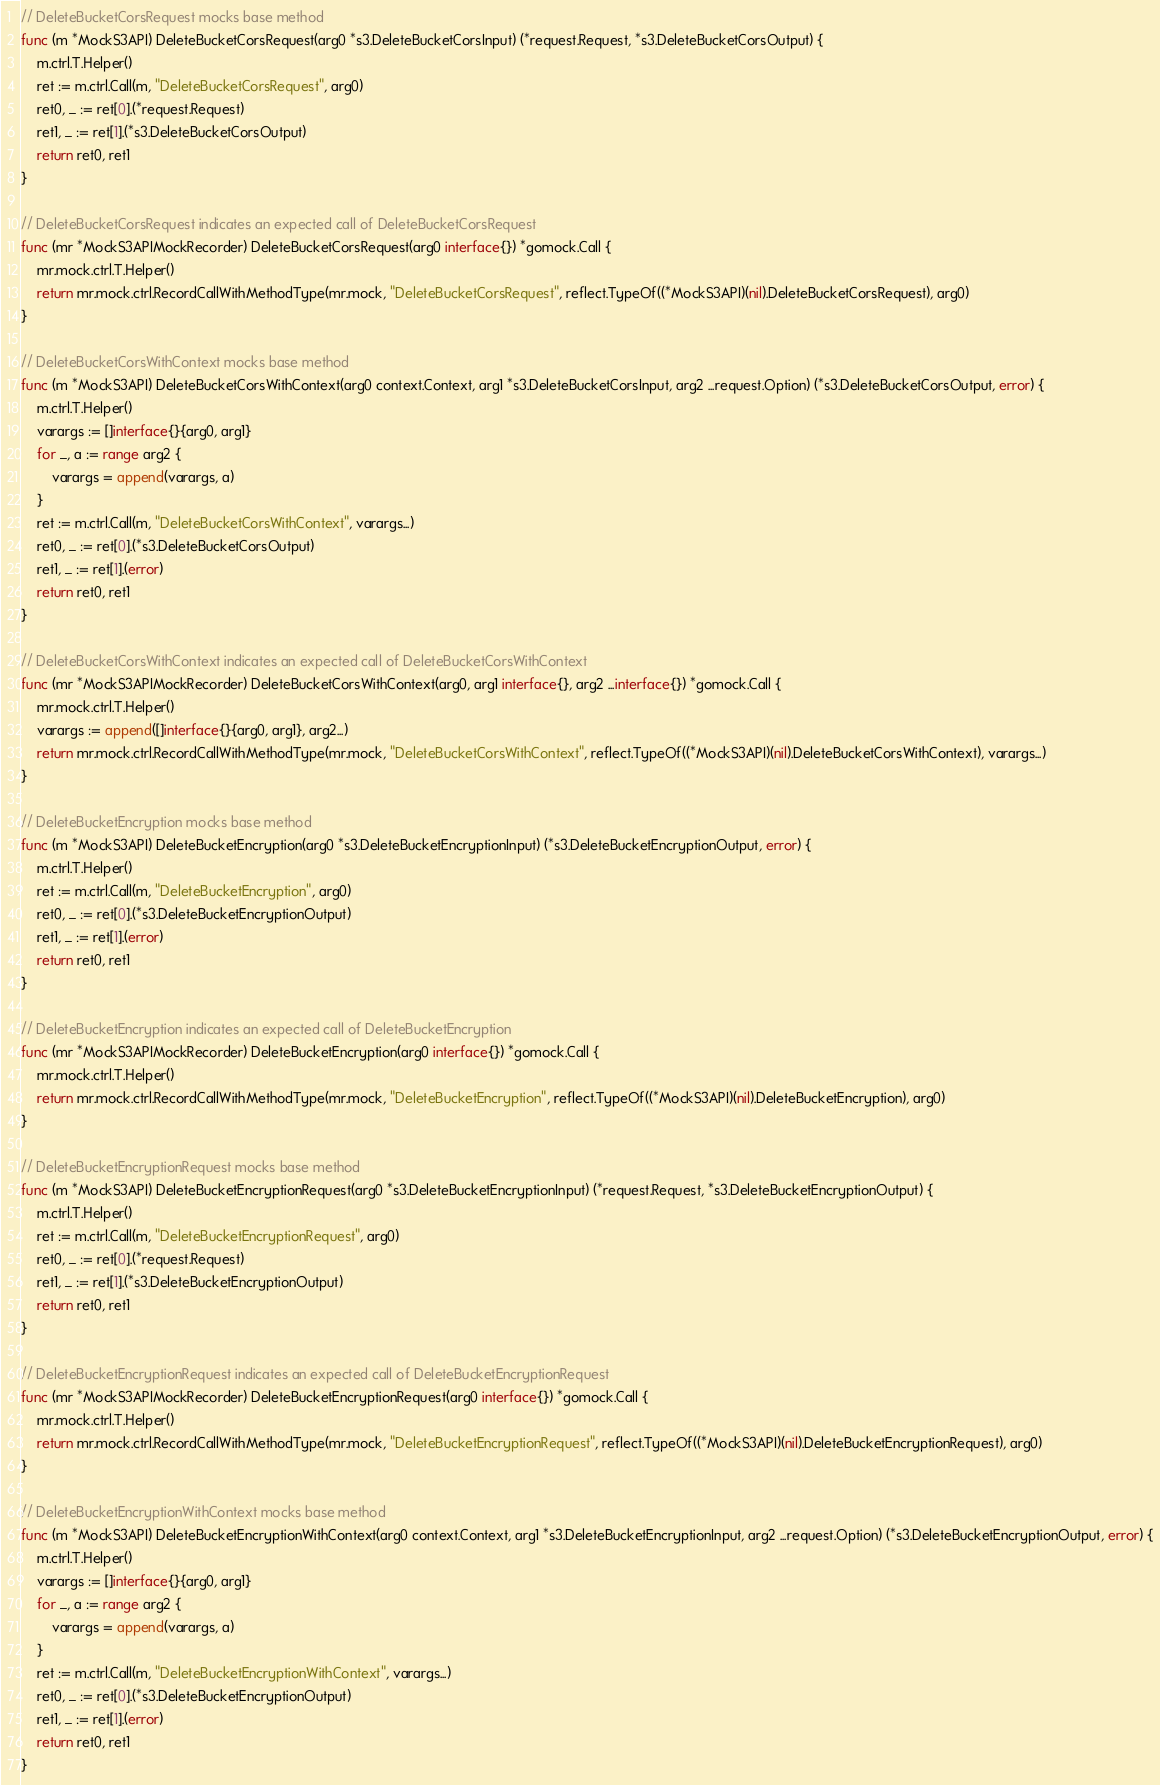Convert code to text. <code><loc_0><loc_0><loc_500><loc_500><_Go_>
// DeleteBucketCorsRequest mocks base method
func (m *MockS3API) DeleteBucketCorsRequest(arg0 *s3.DeleteBucketCorsInput) (*request.Request, *s3.DeleteBucketCorsOutput) {
	m.ctrl.T.Helper()
	ret := m.ctrl.Call(m, "DeleteBucketCorsRequest", arg0)
	ret0, _ := ret[0].(*request.Request)
	ret1, _ := ret[1].(*s3.DeleteBucketCorsOutput)
	return ret0, ret1
}

// DeleteBucketCorsRequest indicates an expected call of DeleteBucketCorsRequest
func (mr *MockS3APIMockRecorder) DeleteBucketCorsRequest(arg0 interface{}) *gomock.Call {
	mr.mock.ctrl.T.Helper()
	return mr.mock.ctrl.RecordCallWithMethodType(mr.mock, "DeleteBucketCorsRequest", reflect.TypeOf((*MockS3API)(nil).DeleteBucketCorsRequest), arg0)
}

// DeleteBucketCorsWithContext mocks base method
func (m *MockS3API) DeleteBucketCorsWithContext(arg0 context.Context, arg1 *s3.DeleteBucketCorsInput, arg2 ...request.Option) (*s3.DeleteBucketCorsOutput, error) {
	m.ctrl.T.Helper()
	varargs := []interface{}{arg0, arg1}
	for _, a := range arg2 {
		varargs = append(varargs, a)
	}
	ret := m.ctrl.Call(m, "DeleteBucketCorsWithContext", varargs...)
	ret0, _ := ret[0].(*s3.DeleteBucketCorsOutput)
	ret1, _ := ret[1].(error)
	return ret0, ret1
}

// DeleteBucketCorsWithContext indicates an expected call of DeleteBucketCorsWithContext
func (mr *MockS3APIMockRecorder) DeleteBucketCorsWithContext(arg0, arg1 interface{}, arg2 ...interface{}) *gomock.Call {
	mr.mock.ctrl.T.Helper()
	varargs := append([]interface{}{arg0, arg1}, arg2...)
	return mr.mock.ctrl.RecordCallWithMethodType(mr.mock, "DeleteBucketCorsWithContext", reflect.TypeOf((*MockS3API)(nil).DeleteBucketCorsWithContext), varargs...)
}

// DeleteBucketEncryption mocks base method
func (m *MockS3API) DeleteBucketEncryption(arg0 *s3.DeleteBucketEncryptionInput) (*s3.DeleteBucketEncryptionOutput, error) {
	m.ctrl.T.Helper()
	ret := m.ctrl.Call(m, "DeleteBucketEncryption", arg0)
	ret0, _ := ret[0].(*s3.DeleteBucketEncryptionOutput)
	ret1, _ := ret[1].(error)
	return ret0, ret1
}

// DeleteBucketEncryption indicates an expected call of DeleteBucketEncryption
func (mr *MockS3APIMockRecorder) DeleteBucketEncryption(arg0 interface{}) *gomock.Call {
	mr.mock.ctrl.T.Helper()
	return mr.mock.ctrl.RecordCallWithMethodType(mr.mock, "DeleteBucketEncryption", reflect.TypeOf((*MockS3API)(nil).DeleteBucketEncryption), arg0)
}

// DeleteBucketEncryptionRequest mocks base method
func (m *MockS3API) DeleteBucketEncryptionRequest(arg0 *s3.DeleteBucketEncryptionInput) (*request.Request, *s3.DeleteBucketEncryptionOutput) {
	m.ctrl.T.Helper()
	ret := m.ctrl.Call(m, "DeleteBucketEncryptionRequest", arg0)
	ret0, _ := ret[0].(*request.Request)
	ret1, _ := ret[1].(*s3.DeleteBucketEncryptionOutput)
	return ret0, ret1
}

// DeleteBucketEncryptionRequest indicates an expected call of DeleteBucketEncryptionRequest
func (mr *MockS3APIMockRecorder) DeleteBucketEncryptionRequest(arg0 interface{}) *gomock.Call {
	mr.mock.ctrl.T.Helper()
	return mr.mock.ctrl.RecordCallWithMethodType(mr.mock, "DeleteBucketEncryptionRequest", reflect.TypeOf((*MockS3API)(nil).DeleteBucketEncryptionRequest), arg0)
}

// DeleteBucketEncryptionWithContext mocks base method
func (m *MockS3API) DeleteBucketEncryptionWithContext(arg0 context.Context, arg1 *s3.DeleteBucketEncryptionInput, arg2 ...request.Option) (*s3.DeleteBucketEncryptionOutput, error) {
	m.ctrl.T.Helper()
	varargs := []interface{}{arg0, arg1}
	for _, a := range arg2 {
		varargs = append(varargs, a)
	}
	ret := m.ctrl.Call(m, "DeleteBucketEncryptionWithContext", varargs...)
	ret0, _ := ret[0].(*s3.DeleteBucketEncryptionOutput)
	ret1, _ := ret[1].(error)
	return ret0, ret1
}
</code> 